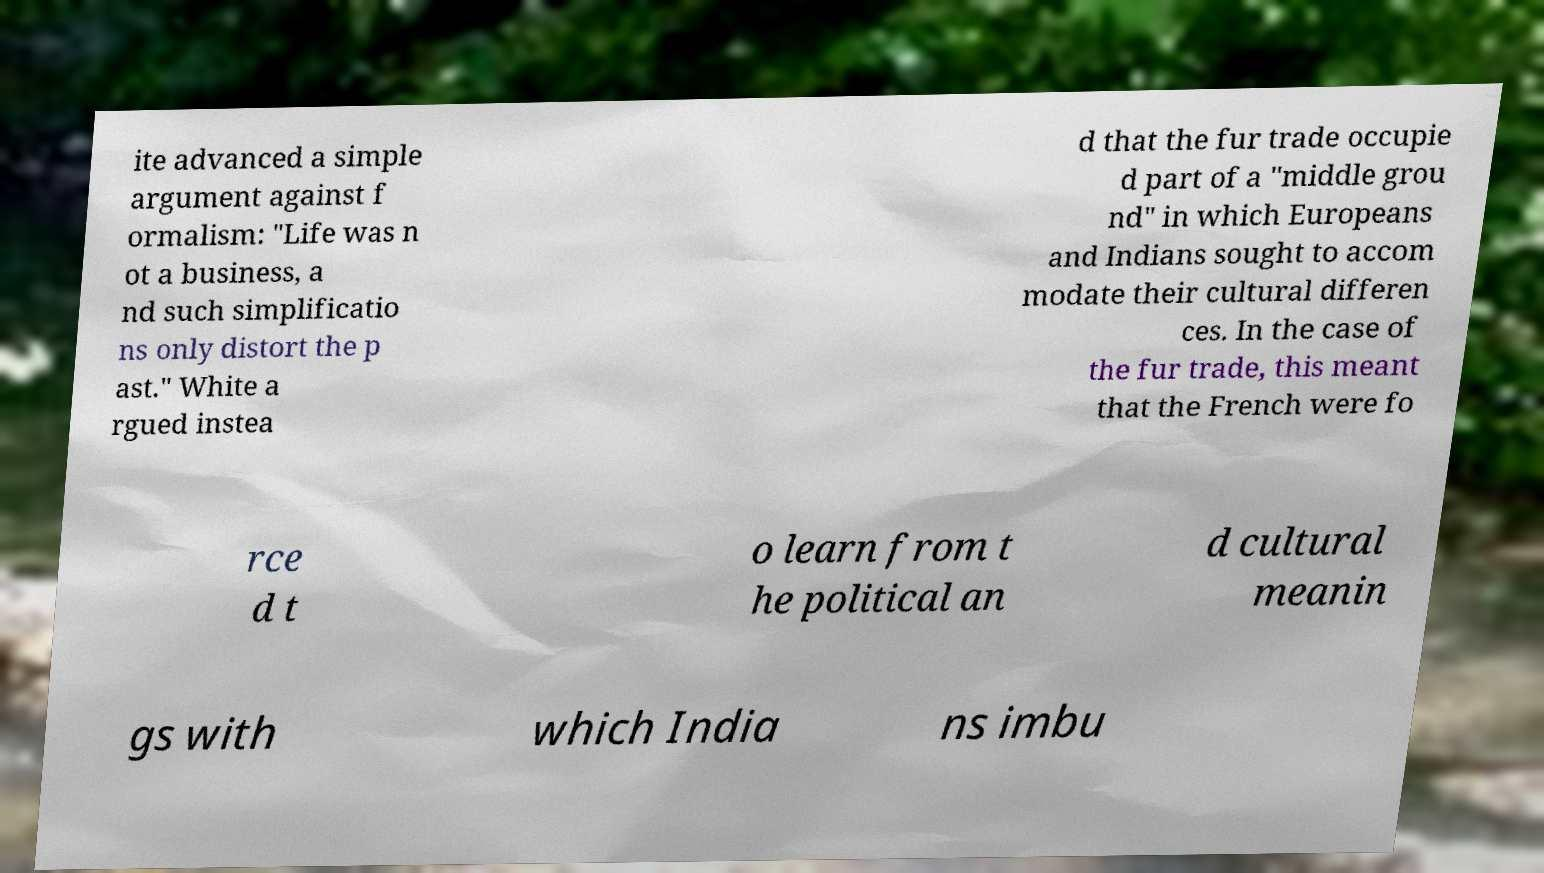Please read and relay the text visible in this image. What does it say? ite advanced a simple argument against f ormalism: "Life was n ot a business, a nd such simplificatio ns only distort the p ast." White a rgued instea d that the fur trade occupie d part of a "middle grou nd" in which Europeans and Indians sought to accom modate their cultural differen ces. In the case of the fur trade, this meant that the French were fo rce d t o learn from t he political an d cultural meanin gs with which India ns imbu 